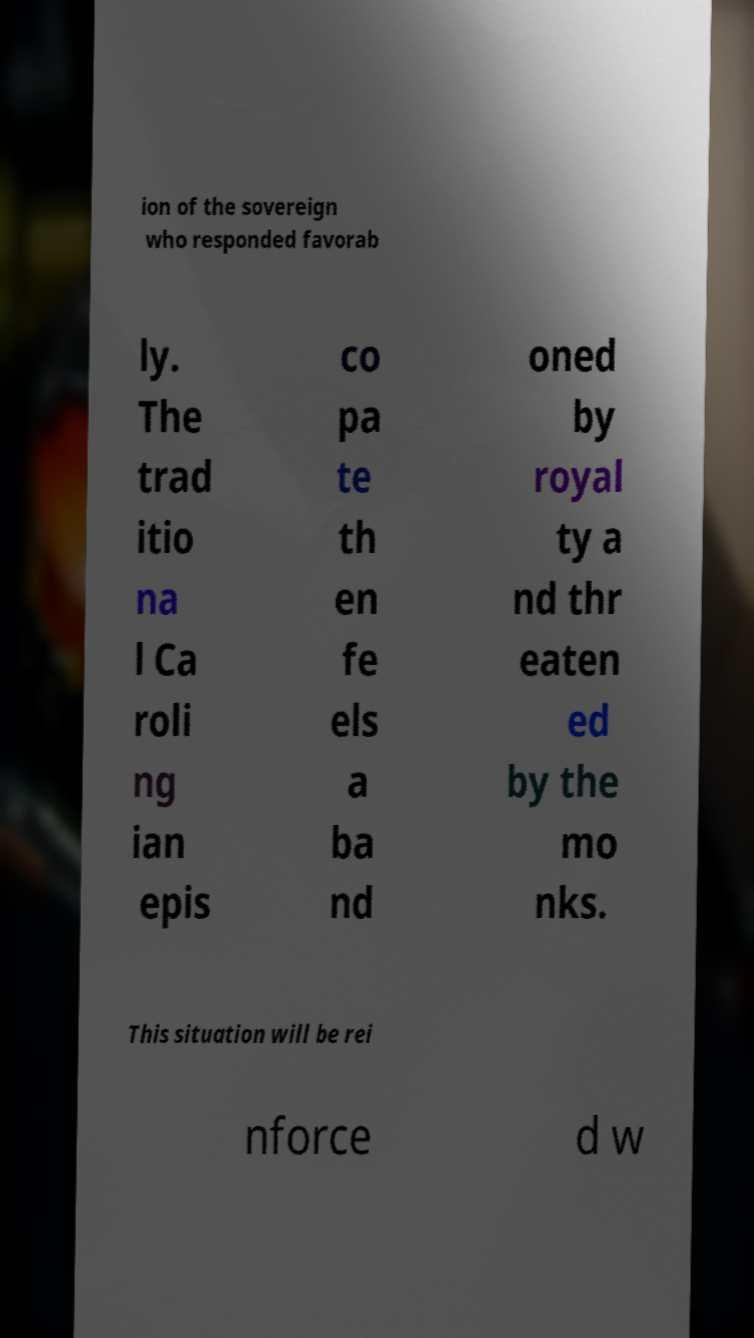Can you read and provide the text displayed in the image?This photo seems to have some interesting text. Can you extract and type it out for me? ion of the sovereign who responded favorab ly. The trad itio na l Ca roli ng ian epis co pa te th en fe els a ba nd oned by royal ty a nd thr eaten ed by the mo nks. This situation will be rei nforce d w 